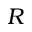Convert formula to latex. <formula><loc_0><loc_0><loc_500><loc_500>R</formula> 